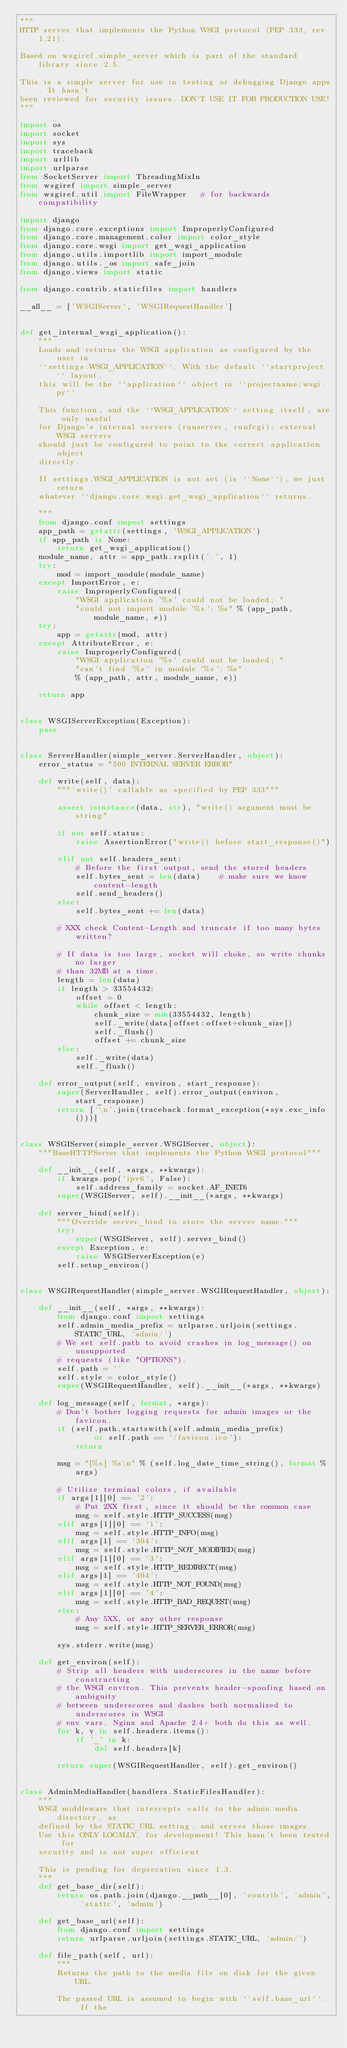<code> <loc_0><loc_0><loc_500><loc_500><_Python_>"""
HTTP server that implements the Python WSGI protocol (PEP 333, rev 1.21).

Based on wsgiref.simple_server which is part of the standard library since 2.5.

This is a simple server for use in testing or debugging Django apps. It hasn't
been reviewed for security issues. DON'T USE IT FOR PRODUCTION USE!
"""

import os
import socket
import sys
import traceback
import urllib
import urlparse
from SocketServer import ThreadingMixIn
from wsgiref import simple_server
from wsgiref.util import FileWrapper   # for backwards compatibility

import django
from django.core.exceptions import ImproperlyConfigured
from django.core.management.color import color_style
from django.core.wsgi import get_wsgi_application
from django.utils.importlib import import_module
from django.utils._os import safe_join
from django.views import static

from django.contrib.staticfiles import handlers

__all__ = ['WSGIServer', 'WSGIRequestHandler']


def get_internal_wsgi_application():
    """
    Loads and returns the WSGI application as configured by the user in
    ``settings.WSGI_APPLICATION``. With the default ``startproject`` layout,
    this will be the ``application`` object in ``projectname/wsgi.py``.

    This function, and the ``WSGI_APPLICATION`` setting itself, are only useful
    for Django's internal servers (runserver, runfcgi); external WSGI servers
    should just be configured to point to the correct application object
    directly.

    If settings.WSGI_APPLICATION is not set (is ``None``), we just return
    whatever ``django.core.wsgi.get_wsgi_application`` returns.

    """
    from django.conf import settings
    app_path = getattr(settings, 'WSGI_APPLICATION')
    if app_path is None:
        return get_wsgi_application()
    module_name, attr = app_path.rsplit('.', 1)
    try:
        mod = import_module(module_name)
    except ImportError, e:
        raise ImproperlyConfigured(
            "WSGI application '%s' could not be loaded; "
            "could not import module '%s': %s" % (app_path, module_name, e))
    try:
        app = getattr(mod, attr)
    except AttributeError, e:
        raise ImproperlyConfigured(
            "WSGI application '%s' could not be loaded; "
            "can't find '%s' in module '%s': %s"
            % (app_path, attr, module_name, e))

    return app


class WSGIServerException(Exception):
    pass


class ServerHandler(simple_server.ServerHandler, object):
    error_status = "500 INTERNAL SERVER ERROR"

    def write(self, data):
        """'write()' callable as specified by PEP 333"""

        assert isinstance(data, str), "write() argument must be string"

        if not self.status:
            raise AssertionError("write() before start_response()")

        elif not self.headers_sent:
            # Before the first output, send the stored headers
            self.bytes_sent = len(data)    # make sure we know content-length
            self.send_headers()
        else:
            self.bytes_sent += len(data)

        # XXX check Content-Length and truncate if too many bytes written?

        # If data is too large, socket will choke, so write chunks no larger
        # than 32MB at a time.
        length = len(data)
        if length > 33554432:
            offset = 0
            while offset < length:
                chunk_size = min(33554432, length)
                self._write(data[offset:offset+chunk_size])
                self._flush()
                offset += chunk_size
        else:
            self._write(data)
            self._flush()

    def error_output(self, environ, start_response):
        super(ServerHandler, self).error_output(environ, start_response)
        return ['\n'.join(traceback.format_exception(*sys.exc_info()))]


class WSGIServer(simple_server.WSGIServer, object):
    """BaseHTTPServer that implements the Python WSGI protocol"""

    def __init__(self, *args, **kwargs):
        if kwargs.pop('ipv6', False):
            self.address_family = socket.AF_INET6
        super(WSGIServer, self).__init__(*args, **kwargs)

    def server_bind(self):
        """Override server_bind to store the server name."""
        try:
            super(WSGIServer, self).server_bind()
        except Exception, e:
            raise WSGIServerException(e)
        self.setup_environ()


class WSGIRequestHandler(simple_server.WSGIRequestHandler, object):

    def __init__(self, *args, **kwargs):
        from django.conf import settings
        self.admin_media_prefix = urlparse.urljoin(settings.STATIC_URL, 'admin/')
        # We set self.path to avoid crashes in log_message() on unsupported
        # requests (like "OPTIONS").
        self.path = ''
        self.style = color_style()
        super(WSGIRequestHandler, self).__init__(*args, **kwargs)

    def log_message(self, format, *args):
        # Don't bother logging requests for admin images or the favicon.
        if (self.path.startswith(self.admin_media_prefix)
                or self.path == '/favicon.ico'):
            return

        msg = "[%s] %s\n" % (self.log_date_time_string(), format % args)

        # Utilize terminal colors, if available
        if args[1][0] == '2':
            # Put 2XX first, since it should be the common case
            msg = self.style.HTTP_SUCCESS(msg)
        elif args[1][0] == '1':
            msg = self.style.HTTP_INFO(msg)
        elif args[1] == '304':
            msg = self.style.HTTP_NOT_MODIFIED(msg)
        elif args[1][0] == '3':
            msg = self.style.HTTP_REDIRECT(msg)
        elif args[1] == '404':
            msg = self.style.HTTP_NOT_FOUND(msg)
        elif args[1][0] == '4':
            msg = self.style.HTTP_BAD_REQUEST(msg)
        else:
            # Any 5XX, or any other response
            msg = self.style.HTTP_SERVER_ERROR(msg)

        sys.stderr.write(msg)

    def get_environ(self):
        # Strip all headers with underscores in the name before constructing
        # the WSGI environ. This prevents header-spoofing based on ambiguity
        # between underscores and dashes both normalized to underscores in WSGI
        # env vars. Nginx and Apache 2.4+ both do this as well.
        for k, v in self.headers.items():
            if '_' in k:
                del self.headers[k]

        return super(WSGIRequestHandler, self).get_environ()


class AdminMediaHandler(handlers.StaticFilesHandler):
    """
    WSGI middleware that intercepts calls to the admin media directory, as
    defined by the STATIC_URL setting, and serves those images.
    Use this ONLY LOCALLY, for development! This hasn't been tested for
    security and is not super efficient.

    This is pending for deprecation since 1.3.
    """
    def get_base_dir(self):
        return os.path.join(django.__path__[0], 'contrib', 'admin', 'static', 'admin')

    def get_base_url(self):
        from django.conf import settings
        return urlparse.urljoin(settings.STATIC_URL, 'admin/')

    def file_path(self, url):
        """
        Returns the path to the media file on disk for the given URL.

        The passed URL is assumed to begin with ``self.base_url``.  If the</code> 